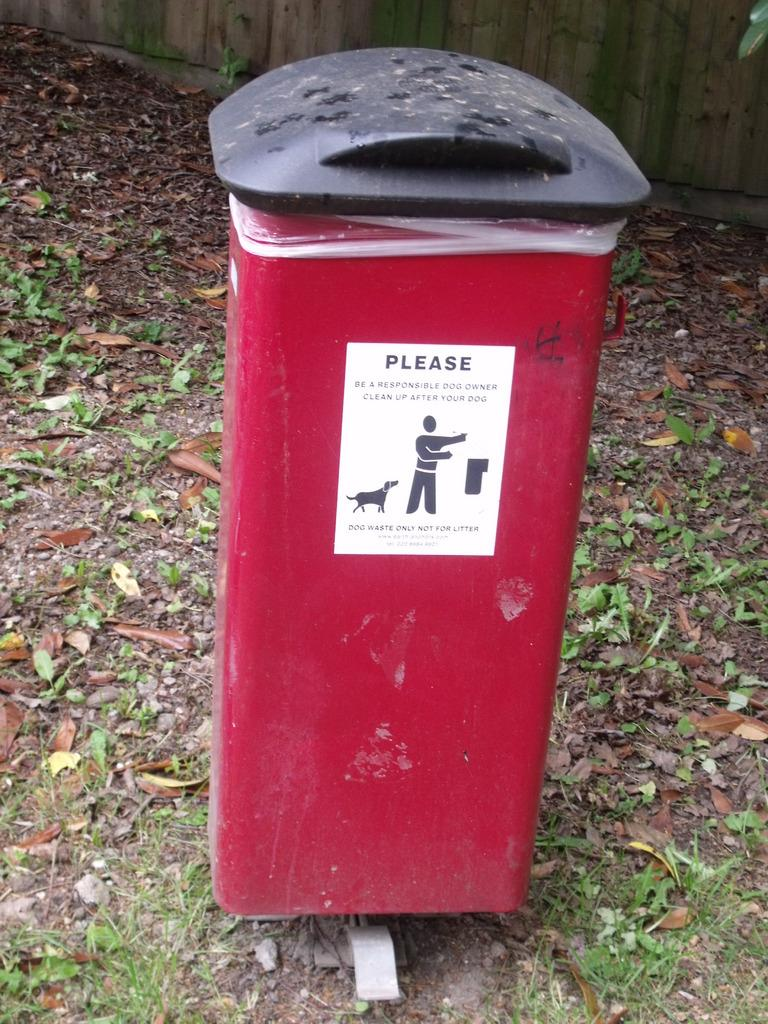<image>
Relay a brief, clear account of the picture shown. The red trash can with the black lid has a sticker that says PLEASE BE A RESPONSIBLE DOG CLEAN UP AFTER YOUR DOG. 